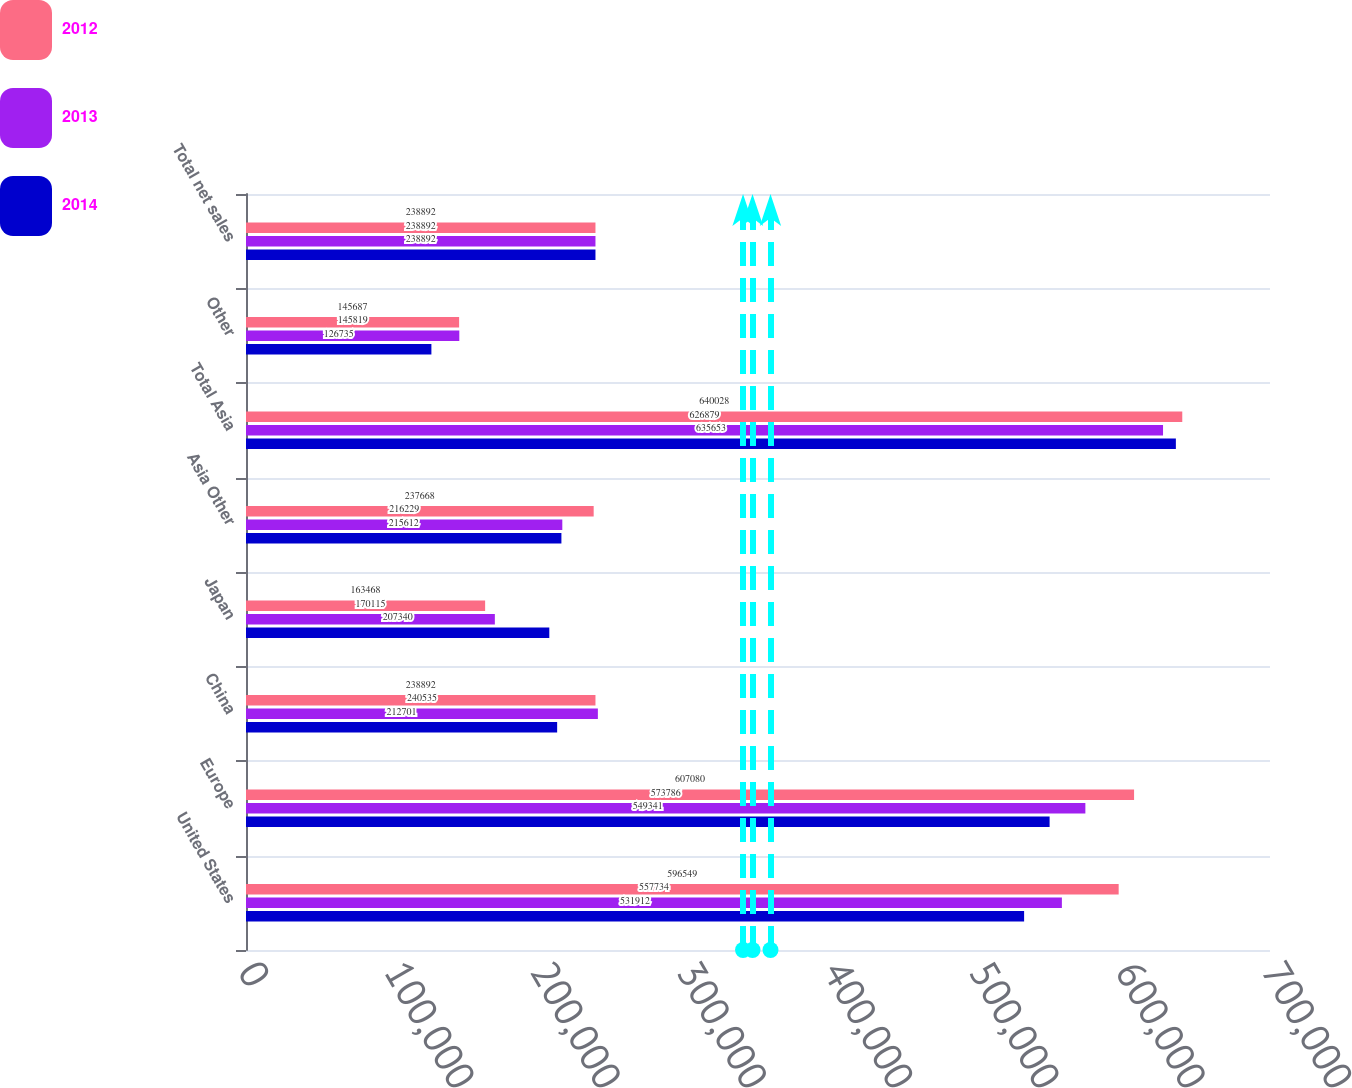Convert chart. <chart><loc_0><loc_0><loc_500><loc_500><stacked_bar_chart><ecel><fcel>United States<fcel>Europe<fcel>China<fcel>Japan<fcel>Asia Other<fcel>Total Asia<fcel>Other<fcel>Total net sales<nl><fcel>2012<fcel>596549<fcel>607080<fcel>238892<fcel>163468<fcel>237668<fcel>640028<fcel>145687<fcel>238892<nl><fcel>2013<fcel>557734<fcel>573786<fcel>240535<fcel>170115<fcel>216229<fcel>626879<fcel>145819<fcel>238892<nl><fcel>2014<fcel>531912<fcel>549341<fcel>212701<fcel>207340<fcel>215612<fcel>635653<fcel>126735<fcel>238892<nl></chart> 